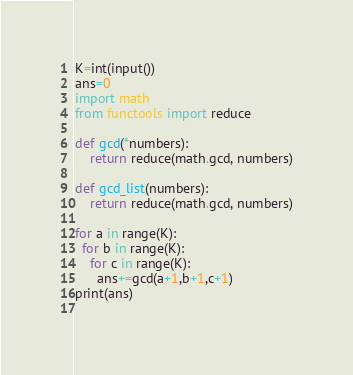<code> <loc_0><loc_0><loc_500><loc_500><_Python_>K=int(input())
ans=0
import math
from functools import reduce

def gcd(*numbers):
    return reduce(math.gcd, numbers)

def gcd_list(numbers):
    return reduce(math.gcd, numbers)
  
for a in range(K):
  for b in range(K):
    for c in range(K):
      ans+=gcd(a+1,b+1,c+1)
print(ans)
      </code> 